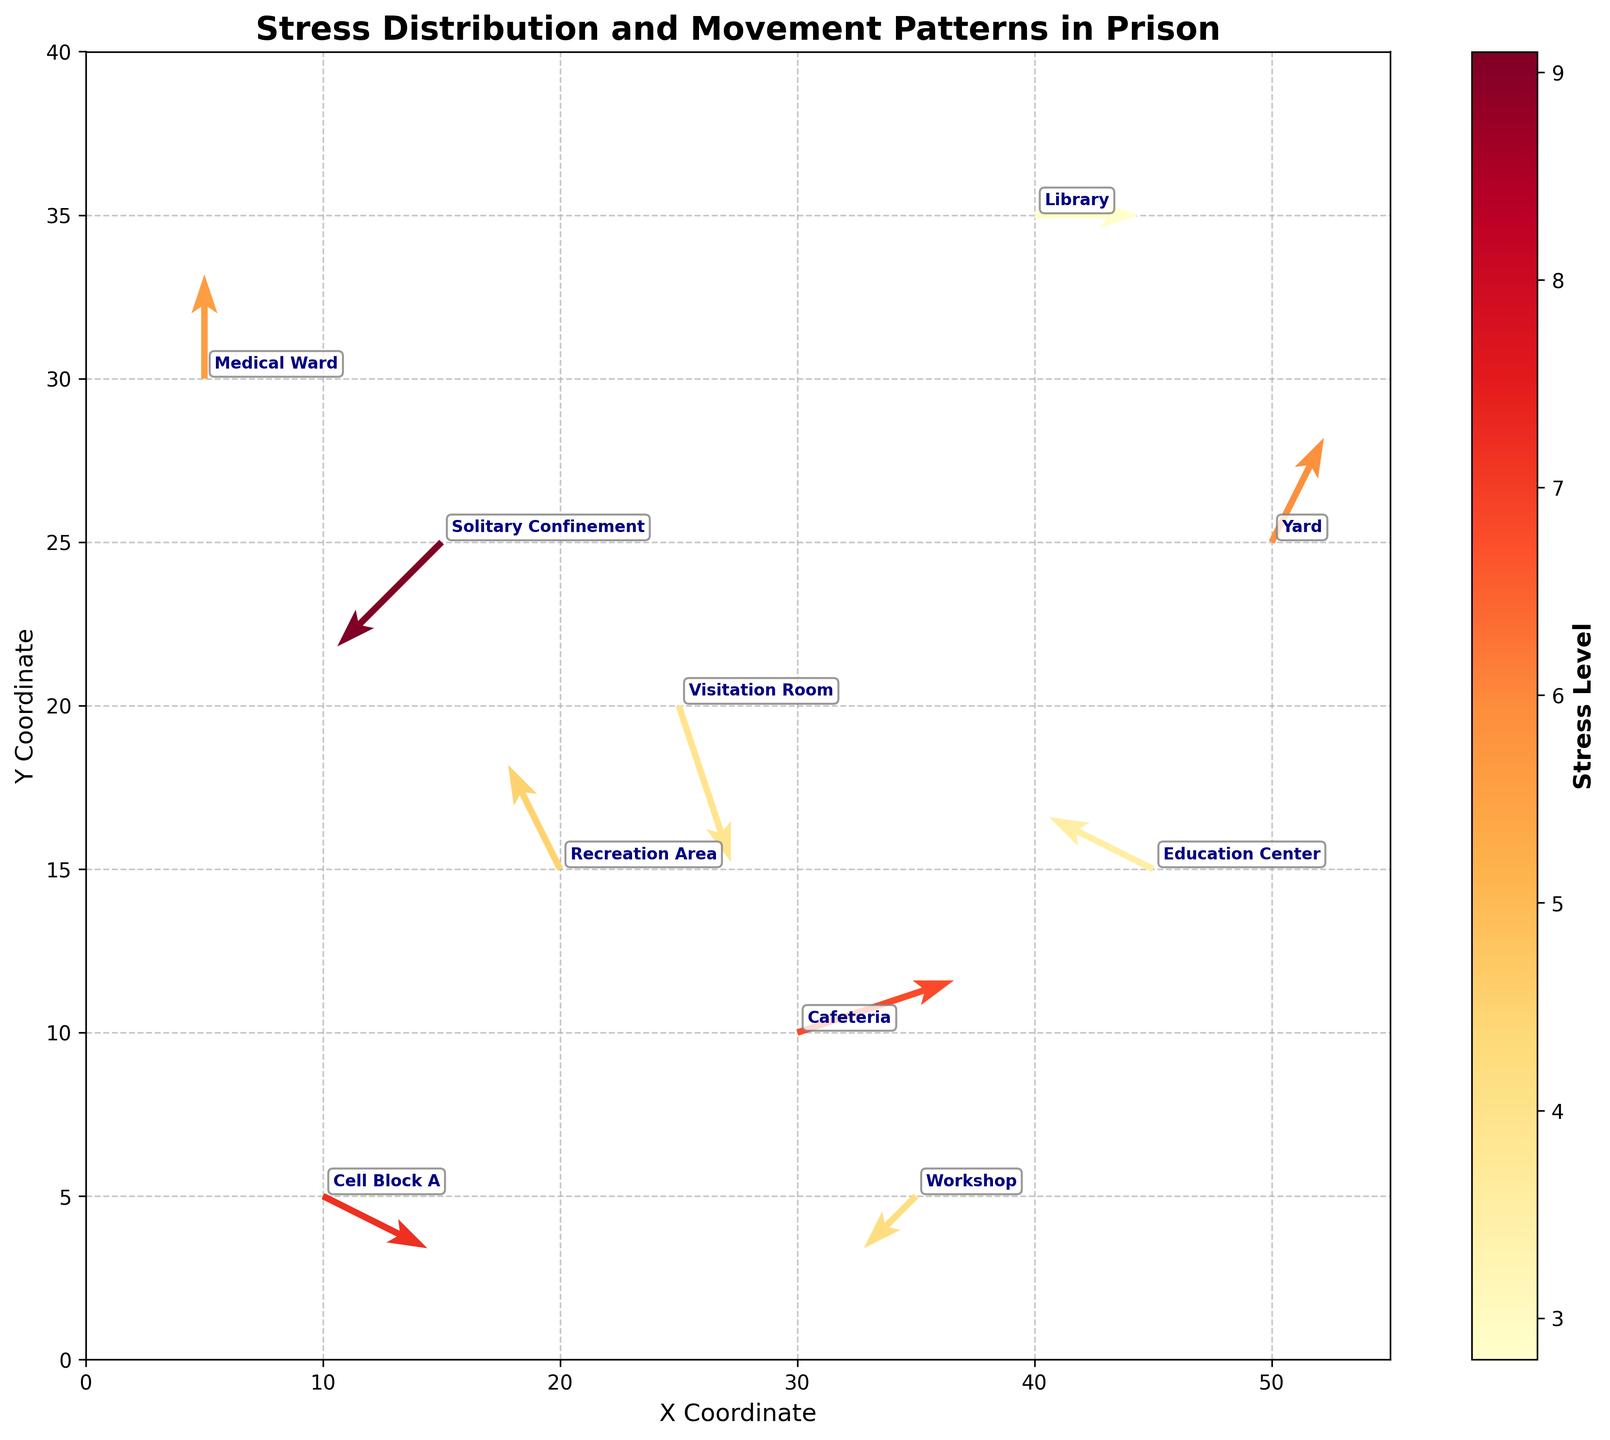What is the title of the figure? The title is typically located at the top of the figure. In this case, it indicates the main focus of the plot.
Answer: Stress Distribution and Movement Patterns in Prison What does the color represent in the quiver plot? The color typically represents an additional variable in the data. Here, the color represents the 'Stress Level'.
Answer: Stress Level What is the range of the X and Y axes? The range of the X and Y axes can be determined by checking the minimum and maximum values displayed on each axis.
Answer: X: 0 to 55, Y: 0 to 40 What location has the highest stress level, and what are its coordinates? By looking at the color intensity and referring to the annotated labels, we can determine the location with the highest stress level and its coordinates. In this case, 'Solitary Confinement' has the highest stress level of 9.1, located at coordinates (15, 25).
Answer: Solitary Confinement at (15, 25) How does the movement pattern differ between Cell Block A and the Yard? The arrows in the quiver plot indicate movement patterns. For Cell Block A, the arrow points right and slightly down (2, -1). For the Yard, the arrow points right and up (1, 2).
Answer: Cell Block A: right and down, Yard: right and up Which area has the lowest stress level, and what direction is the movement? The color bar indicates stress levels, and the location with the lightest color represents the lowest stress level, which is the Library with a stress level of 2.8. The movement direction is right (2, 0).
Answer: Library, right What's the average stress level across all locations? Add all stress levels (7.2, 4.5, 6.8, 9.1, 3.9, 5.6, 4.2, 2.8, 3.5, 5.9) and divide by the number of data points (10): (7.2 + 4.5 + 6.8 + 9.1 + 3.9 + 5.6 + 4.2 + 2.8 + 3.5 + 5.9) / 10 = 5.35
Answer: 5.35 Which two locations have stress levels greater than 7? By referring to the color intensities and annotations, the two locations with stress levels greater than 7 are 'Cell Block A' (7.2) and 'Solitary Confinement' (9.1).
Answer: Cell Block A and Solitary Confinement Which location has a movement pattern that includes both upward and leftward components? The upward movement is indicated by positive V values, and leftward movement by negative U values. 'Recreation Area' fits this pattern with movement (-1, 2).
Answer: Recreation Area How can you describe the movement pattern in the Medical Ward based on the quiver plot? The arrow direction in the Medical Ward is strictly upward, with components (0, 2). This indicates no horizontal movement but a vertical movement upward.
Answer: Upward movement with no horizontal deviation 